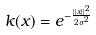<formula> <loc_0><loc_0><loc_500><loc_500>k ( x ) = e ^ { - \frac { | | x | | ^ { 2 } } { 2 \sigma ^ { 2 } } }</formula> 